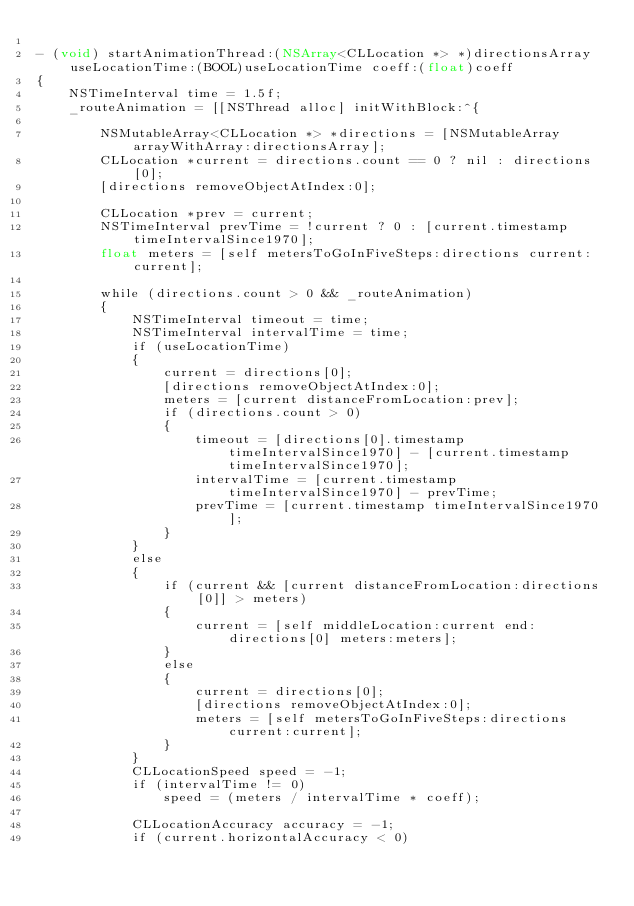Convert code to text. <code><loc_0><loc_0><loc_500><loc_500><_ObjectiveC_>
- (void) startAnimationThread:(NSArray<CLLocation *> *)directionsArray useLocationTime:(BOOL)useLocationTime coeff:(float)coeff
{
    NSTimeInterval time = 1.5f;
    _routeAnimation = [[NSThread alloc] initWithBlock:^{
        
        NSMutableArray<CLLocation *> *directions = [NSMutableArray arrayWithArray:directionsArray];
        CLLocation *current = directions.count == 0 ? nil : directions[0];
        [directions removeObjectAtIndex:0];
        
        CLLocation *prev = current;
        NSTimeInterval prevTime = !current ? 0 : [current.timestamp timeIntervalSince1970];
        float meters = [self metersToGoInFiveSteps:directions current:current];

        while (directions.count > 0 && _routeAnimation)
        {
            NSTimeInterval timeout = time;
            NSTimeInterval intervalTime = time;
            if (useLocationTime)
            {
                current = directions[0];
                [directions removeObjectAtIndex:0];
                meters = [current distanceFromLocation:prev];
                if (directions.count > 0)
                {
                    timeout = [directions[0].timestamp timeIntervalSince1970] - [current.timestamp timeIntervalSince1970];
                    intervalTime = [current.timestamp timeIntervalSince1970] - prevTime;
                    prevTime = [current.timestamp timeIntervalSince1970];
                }
            }
            else
            {
                if (current && [current distanceFromLocation:directions[0]] > meters)
                {
                    current = [self middleLocation:current end:directions[0] meters:meters];
                }
                else
                {
                    current = directions[0];
                    [directions removeObjectAtIndex:0];
                    meters = [self metersToGoInFiveSteps:directions current:current];
                }
            }
            CLLocationSpeed speed = -1;
            if (intervalTime != 0)
                speed = (meters / intervalTime * coeff);
            
            CLLocationAccuracy accuracy = -1;
            if (current.horizontalAccuracy < 0)</code> 